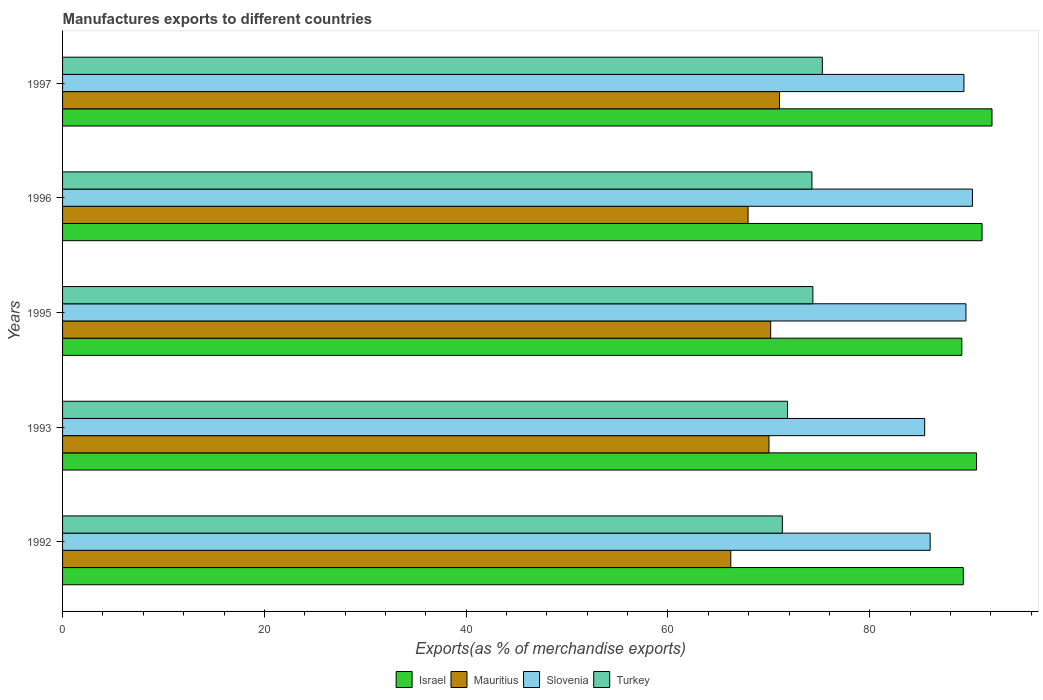How many different coloured bars are there?
Your answer should be compact. 4. Are the number of bars per tick equal to the number of legend labels?
Your answer should be very brief. Yes. Are the number of bars on each tick of the Y-axis equal?
Your answer should be compact. Yes. How many bars are there on the 3rd tick from the top?
Offer a very short reply. 4. What is the percentage of exports to different countries in Israel in 1992?
Give a very brief answer. 89.27. Across all years, what is the maximum percentage of exports to different countries in Turkey?
Provide a short and direct response. 75.3. Across all years, what is the minimum percentage of exports to different countries in Turkey?
Ensure brevity in your answer.  71.34. In which year was the percentage of exports to different countries in Slovenia maximum?
Make the answer very short. 1996. In which year was the percentage of exports to different countries in Slovenia minimum?
Your response must be concise. 1993. What is the total percentage of exports to different countries in Mauritius in the graph?
Give a very brief answer. 345.41. What is the difference between the percentage of exports to different countries in Turkey in 1992 and that in 1996?
Offer a very short reply. -2.93. What is the difference between the percentage of exports to different countries in Mauritius in 1992 and the percentage of exports to different countries in Slovenia in 1995?
Your answer should be compact. -23.31. What is the average percentage of exports to different countries in Israel per year?
Provide a succinct answer. 90.45. In the year 1993, what is the difference between the percentage of exports to different countries in Israel and percentage of exports to different countries in Turkey?
Make the answer very short. 18.73. In how many years, is the percentage of exports to different countries in Mauritius greater than 16 %?
Make the answer very short. 5. What is the ratio of the percentage of exports to different countries in Mauritius in 1992 to that in 1995?
Your response must be concise. 0.94. What is the difference between the highest and the second highest percentage of exports to different countries in Slovenia?
Make the answer very short. 0.64. What is the difference between the highest and the lowest percentage of exports to different countries in Turkey?
Make the answer very short. 3.96. What does the 2nd bar from the top in 1992 represents?
Ensure brevity in your answer.  Slovenia. What does the 3rd bar from the bottom in 1995 represents?
Your answer should be very brief. Slovenia. Is it the case that in every year, the sum of the percentage of exports to different countries in Slovenia and percentage of exports to different countries in Mauritius is greater than the percentage of exports to different countries in Israel?
Provide a short and direct response. Yes. How many bars are there?
Your response must be concise. 20. Are the values on the major ticks of X-axis written in scientific E-notation?
Keep it short and to the point. No. Where does the legend appear in the graph?
Offer a terse response. Bottom center. How many legend labels are there?
Offer a terse response. 4. What is the title of the graph?
Make the answer very short. Manufactures exports to different countries. What is the label or title of the X-axis?
Give a very brief answer. Exports(as % of merchandise exports). What is the label or title of the Y-axis?
Ensure brevity in your answer.  Years. What is the Exports(as % of merchandise exports) in Israel in 1992?
Your answer should be compact. 89.27. What is the Exports(as % of merchandise exports) of Mauritius in 1992?
Your answer should be very brief. 66.23. What is the Exports(as % of merchandise exports) of Slovenia in 1992?
Your answer should be compact. 85.99. What is the Exports(as % of merchandise exports) of Turkey in 1992?
Your answer should be compact. 71.34. What is the Exports(as % of merchandise exports) of Israel in 1993?
Offer a terse response. 90.58. What is the Exports(as % of merchandise exports) in Mauritius in 1993?
Ensure brevity in your answer.  70.01. What is the Exports(as % of merchandise exports) in Slovenia in 1993?
Give a very brief answer. 85.44. What is the Exports(as % of merchandise exports) of Turkey in 1993?
Provide a succinct answer. 71.85. What is the Exports(as % of merchandise exports) of Israel in 1995?
Offer a very short reply. 89.13. What is the Exports(as % of merchandise exports) in Mauritius in 1995?
Offer a very short reply. 70.18. What is the Exports(as % of merchandise exports) in Slovenia in 1995?
Offer a terse response. 89.53. What is the Exports(as % of merchandise exports) of Turkey in 1995?
Provide a short and direct response. 74.36. What is the Exports(as % of merchandise exports) of Israel in 1996?
Ensure brevity in your answer.  91.13. What is the Exports(as % of merchandise exports) in Mauritius in 1996?
Your answer should be very brief. 67.94. What is the Exports(as % of merchandise exports) of Slovenia in 1996?
Your response must be concise. 90.18. What is the Exports(as % of merchandise exports) in Turkey in 1996?
Keep it short and to the point. 74.27. What is the Exports(as % of merchandise exports) in Israel in 1997?
Keep it short and to the point. 92.12. What is the Exports(as % of merchandise exports) of Mauritius in 1997?
Your response must be concise. 71.05. What is the Exports(as % of merchandise exports) in Slovenia in 1997?
Make the answer very short. 89.33. What is the Exports(as % of merchandise exports) in Turkey in 1997?
Ensure brevity in your answer.  75.3. Across all years, what is the maximum Exports(as % of merchandise exports) of Israel?
Your answer should be compact. 92.12. Across all years, what is the maximum Exports(as % of merchandise exports) in Mauritius?
Offer a terse response. 71.05. Across all years, what is the maximum Exports(as % of merchandise exports) in Slovenia?
Your response must be concise. 90.18. Across all years, what is the maximum Exports(as % of merchandise exports) in Turkey?
Provide a succinct answer. 75.3. Across all years, what is the minimum Exports(as % of merchandise exports) in Israel?
Your response must be concise. 89.13. Across all years, what is the minimum Exports(as % of merchandise exports) of Mauritius?
Give a very brief answer. 66.23. Across all years, what is the minimum Exports(as % of merchandise exports) in Slovenia?
Your answer should be very brief. 85.44. Across all years, what is the minimum Exports(as % of merchandise exports) of Turkey?
Provide a succinct answer. 71.34. What is the total Exports(as % of merchandise exports) of Israel in the graph?
Provide a short and direct response. 452.23. What is the total Exports(as % of merchandise exports) in Mauritius in the graph?
Your answer should be very brief. 345.41. What is the total Exports(as % of merchandise exports) of Slovenia in the graph?
Ensure brevity in your answer.  440.47. What is the total Exports(as % of merchandise exports) in Turkey in the graph?
Your answer should be very brief. 367.12. What is the difference between the Exports(as % of merchandise exports) of Israel in 1992 and that in 1993?
Your answer should be very brief. -1.31. What is the difference between the Exports(as % of merchandise exports) of Mauritius in 1992 and that in 1993?
Give a very brief answer. -3.78. What is the difference between the Exports(as % of merchandise exports) in Slovenia in 1992 and that in 1993?
Provide a succinct answer. 0.54. What is the difference between the Exports(as % of merchandise exports) in Turkey in 1992 and that in 1993?
Keep it short and to the point. -0.51. What is the difference between the Exports(as % of merchandise exports) of Israel in 1992 and that in 1995?
Give a very brief answer. 0.15. What is the difference between the Exports(as % of merchandise exports) of Mauritius in 1992 and that in 1995?
Provide a short and direct response. -3.95. What is the difference between the Exports(as % of merchandise exports) in Slovenia in 1992 and that in 1995?
Give a very brief answer. -3.55. What is the difference between the Exports(as % of merchandise exports) in Turkey in 1992 and that in 1995?
Ensure brevity in your answer.  -3.03. What is the difference between the Exports(as % of merchandise exports) of Israel in 1992 and that in 1996?
Provide a short and direct response. -1.86. What is the difference between the Exports(as % of merchandise exports) of Mauritius in 1992 and that in 1996?
Your answer should be very brief. -1.71. What is the difference between the Exports(as % of merchandise exports) of Slovenia in 1992 and that in 1996?
Offer a terse response. -4.19. What is the difference between the Exports(as % of merchandise exports) of Turkey in 1992 and that in 1996?
Provide a short and direct response. -2.93. What is the difference between the Exports(as % of merchandise exports) in Israel in 1992 and that in 1997?
Offer a terse response. -2.85. What is the difference between the Exports(as % of merchandise exports) of Mauritius in 1992 and that in 1997?
Your response must be concise. -4.83. What is the difference between the Exports(as % of merchandise exports) of Slovenia in 1992 and that in 1997?
Offer a terse response. -3.35. What is the difference between the Exports(as % of merchandise exports) in Turkey in 1992 and that in 1997?
Keep it short and to the point. -3.96. What is the difference between the Exports(as % of merchandise exports) of Israel in 1993 and that in 1995?
Ensure brevity in your answer.  1.46. What is the difference between the Exports(as % of merchandise exports) of Mauritius in 1993 and that in 1995?
Keep it short and to the point. -0.17. What is the difference between the Exports(as % of merchandise exports) in Slovenia in 1993 and that in 1995?
Give a very brief answer. -4.09. What is the difference between the Exports(as % of merchandise exports) of Turkey in 1993 and that in 1995?
Your response must be concise. -2.52. What is the difference between the Exports(as % of merchandise exports) of Israel in 1993 and that in 1996?
Give a very brief answer. -0.55. What is the difference between the Exports(as % of merchandise exports) in Mauritius in 1993 and that in 1996?
Offer a very short reply. 2.07. What is the difference between the Exports(as % of merchandise exports) in Slovenia in 1993 and that in 1996?
Your answer should be compact. -4.73. What is the difference between the Exports(as % of merchandise exports) of Turkey in 1993 and that in 1996?
Offer a terse response. -2.42. What is the difference between the Exports(as % of merchandise exports) in Israel in 1993 and that in 1997?
Offer a terse response. -1.54. What is the difference between the Exports(as % of merchandise exports) of Mauritius in 1993 and that in 1997?
Your answer should be compact. -1.04. What is the difference between the Exports(as % of merchandise exports) in Slovenia in 1993 and that in 1997?
Keep it short and to the point. -3.89. What is the difference between the Exports(as % of merchandise exports) of Turkey in 1993 and that in 1997?
Your answer should be compact. -3.45. What is the difference between the Exports(as % of merchandise exports) of Israel in 1995 and that in 1996?
Ensure brevity in your answer.  -2.01. What is the difference between the Exports(as % of merchandise exports) in Mauritius in 1995 and that in 1996?
Your answer should be very brief. 2.24. What is the difference between the Exports(as % of merchandise exports) in Slovenia in 1995 and that in 1996?
Your answer should be compact. -0.64. What is the difference between the Exports(as % of merchandise exports) of Turkey in 1995 and that in 1996?
Offer a very short reply. 0.09. What is the difference between the Exports(as % of merchandise exports) of Israel in 1995 and that in 1997?
Provide a short and direct response. -2.99. What is the difference between the Exports(as % of merchandise exports) of Mauritius in 1995 and that in 1997?
Your response must be concise. -0.87. What is the difference between the Exports(as % of merchandise exports) of Slovenia in 1995 and that in 1997?
Make the answer very short. 0.2. What is the difference between the Exports(as % of merchandise exports) of Turkey in 1995 and that in 1997?
Give a very brief answer. -0.93. What is the difference between the Exports(as % of merchandise exports) in Israel in 1996 and that in 1997?
Ensure brevity in your answer.  -0.99. What is the difference between the Exports(as % of merchandise exports) of Mauritius in 1996 and that in 1997?
Offer a very short reply. -3.12. What is the difference between the Exports(as % of merchandise exports) of Slovenia in 1996 and that in 1997?
Ensure brevity in your answer.  0.84. What is the difference between the Exports(as % of merchandise exports) of Turkey in 1996 and that in 1997?
Provide a succinct answer. -1.03. What is the difference between the Exports(as % of merchandise exports) of Israel in 1992 and the Exports(as % of merchandise exports) of Mauritius in 1993?
Your answer should be very brief. 19.26. What is the difference between the Exports(as % of merchandise exports) in Israel in 1992 and the Exports(as % of merchandise exports) in Slovenia in 1993?
Make the answer very short. 3.83. What is the difference between the Exports(as % of merchandise exports) in Israel in 1992 and the Exports(as % of merchandise exports) in Turkey in 1993?
Ensure brevity in your answer.  17.42. What is the difference between the Exports(as % of merchandise exports) of Mauritius in 1992 and the Exports(as % of merchandise exports) of Slovenia in 1993?
Give a very brief answer. -19.21. What is the difference between the Exports(as % of merchandise exports) in Mauritius in 1992 and the Exports(as % of merchandise exports) in Turkey in 1993?
Your answer should be compact. -5.62. What is the difference between the Exports(as % of merchandise exports) in Slovenia in 1992 and the Exports(as % of merchandise exports) in Turkey in 1993?
Provide a succinct answer. 14.14. What is the difference between the Exports(as % of merchandise exports) of Israel in 1992 and the Exports(as % of merchandise exports) of Mauritius in 1995?
Make the answer very short. 19.09. What is the difference between the Exports(as % of merchandise exports) of Israel in 1992 and the Exports(as % of merchandise exports) of Slovenia in 1995?
Ensure brevity in your answer.  -0.26. What is the difference between the Exports(as % of merchandise exports) in Israel in 1992 and the Exports(as % of merchandise exports) in Turkey in 1995?
Keep it short and to the point. 14.91. What is the difference between the Exports(as % of merchandise exports) in Mauritius in 1992 and the Exports(as % of merchandise exports) in Slovenia in 1995?
Offer a terse response. -23.31. What is the difference between the Exports(as % of merchandise exports) of Mauritius in 1992 and the Exports(as % of merchandise exports) of Turkey in 1995?
Offer a terse response. -8.14. What is the difference between the Exports(as % of merchandise exports) of Slovenia in 1992 and the Exports(as % of merchandise exports) of Turkey in 1995?
Provide a short and direct response. 11.62. What is the difference between the Exports(as % of merchandise exports) in Israel in 1992 and the Exports(as % of merchandise exports) in Mauritius in 1996?
Offer a very short reply. 21.33. What is the difference between the Exports(as % of merchandise exports) of Israel in 1992 and the Exports(as % of merchandise exports) of Slovenia in 1996?
Ensure brevity in your answer.  -0.9. What is the difference between the Exports(as % of merchandise exports) in Israel in 1992 and the Exports(as % of merchandise exports) in Turkey in 1996?
Provide a succinct answer. 15. What is the difference between the Exports(as % of merchandise exports) in Mauritius in 1992 and the Exports(as % of merchandise exports) in Slovenia in 1996?
Your answer should be compact. -23.95. What is the difference between the Exports(as % of merchandise exports) of Mauritius in 1992 and the Exports(as % of merchandise exports) of Turkey in 1996?
Keep it short and to the point. -8.04. What is the difference between the Exports(as % of merchandise exports) of Slovenia in 1992 and the Exports(as % of merchandise exports) of Turkey in 1996?
Ensure brevity in your answer.  11.72. What is the difference between the Exports(as % of merchandise exports) in Israel in 1992 and the Exports(as % of merchandise exports) in Mauritius in 1997?
Provide a short and direct response. 18.22. What is the difference between the Exports(as % of merchandise exports) in Israel in 1992 and the Exports(as % of merchandise exports) in Slovenia in 1997?
Make the answer very short. -0.06. What is the difference between the Exports(as % of merchandise exports) of Israel in 1992 and the Exports(as % of merchandise exports) of Turkey in 1997?
Provide a succinct answer. 13.97. What is the difference between the Exports(as % of merchandise exports) in Mauritius in 1992 and the Exports(as % of merchandise exports) in Slovenia in 1997?
Offer a terse response. -23.11. What is the difference between the Exports(as % of merchandise exports) of Mauritius in 1992 and the Exports(as % of merchandise exports) of Turkey in 1997?
Provide a succinct answer. -9.07. What is the difference between the Exports(as % of merchandise exports) in Slovenia in 1992 and the Exports(as % of merchandise exports) in Turkey in 1997?
Your response must be concise. 10.69. What is the difference between the Exports(as % of merchandise exports) in Israel in 1993 and the Exports(as % of merchandise exports) in Mauritius in 1995?
Make the answer very short. 20.4. What is the difference between the Exports(as % of merchandise exports) in Israel in 1993 and the Exports(as % of merchandise exports) in Slovenia in 1995?
Offer a very short reply. 1.05. What is the difference between the Exports(as % of merchandise exports) in Israel in 1993 and the Exports(as % of merchandise exports) in Turkey in 1995?
Your answer should be compact. 16.22. What is the difference between the Exports(as % of merchandise exports) in Mauritius in 1993 and the Exports(as % of merchandise exports) in Slovenia in 1995?
Keep it short and to the point. -19.52. What is the difference between the Exports(as % of merchandise exports) in Mauritius in 1993 and the Exports(as % of merchandise exports) in Turkey in 1995?
Offer a terse response. -4.35. What is the difference between the Exports(as % of merchandise exports) in Slovenia in 1993 and the Exports(as % of merchandise exports) in Turkey in 1995?
Your answer should be very brief. 11.08. What is the difference between the Exports(as % of merchandise exports) in Israel in 1993 and the Exports(as % of merchandise exports) in Mauritius in 1996?
Your response must be concise. 22.64. What is the difference between the Exports(as % of merchandise exports) of Israel in 1993 and the Exports(as % of merchandise exports) of Slovenia in 1996?
Offer a very short reply. 0.41. What is the difference between the Exports(as % of merchandise exports) in Israel in 1993 and the Exports(as % of merchandise exports) in Turkey in 1996?
Your answer should be compact. 16.31. What is the difference between the Exports(as % of merchandise exports) of Mauritius in 1993 and the Exports(as % of merchandise exports) of Slovenia in 1996?
Give a very brief answer. -20.16. What is the difference between the Exports(as % of merchandise exports) of Mauritius in 1993 and the Exports(as % of merchandise exports) of Turkey in 1996?
Your answer should be compact. -4.26. What is the difference between the Exports(as % of merchandise exports) in Slovenia in 1993 and the Exports(as % of merchandise exports) in Turkey in 1996?
Offer a very short reply. 11.17. What is the difference between the Exports(as % of merchandise exports) in Israel in 1993 and the Exports(as % of merchandise exports) in Mauritius in 1997?
Make the answer very short. 19.53. What is the difference between the Exports(as % of merchandise exports) in Israel in 1993 and the Exports(as % of merchandise exports) in Slovenia in 1997?
Keep it short and to the point. 1.25. What is the difference between the Exports(as % of merchandise exports) of Israel in 1993 and the Exports(as % of merchandise exports) of Turkey in 1997?
Your response must be concise. 15.28. What is the difference between the Exports(as % of merchandise exports) in Mauritius in 1993 and the Exports(as % of merchandise exports) in Slovenia in 1997?
Provide a short and direct response. -19.32. What is the difference between the Exports(as % of merchandise exports) in Mauritius in 1993 and the Exports(as % of merchandise exports) in Turkey in 1997?
Make the answer very short. -5.29. What is the difference between the Exports(as % of merchandise exports) of Slovenia in 1993 and the Exports(as % of merchandise exports) of Turkey in 1997?
Make the answer very short. 10.14. What is the difference between the Exports(as % of merchandise exports) of Israel in 1995 and the Exports(as % of merchandise exports) of Mauritius in 1996?
Make the answer very short. 21.19. What is the difference between the Exports(as % of merchandise exports) in Israel in 1995 and the Exports(as % of merchandise exports) in Slovenia in 1996?
Provide a succinct answer. -1.05. What is the difference between the Exports(as % of merchandise exports) in Israel in 1995 and the Exports(as % of merchandise exports) in Turkey in 1996?
Your answer should be compact. 14.86. What is the difference between the Exports(as % of merchandise exports) in Mauritius in 1995 and the Exports(as % of merchandise exports) in Slovenia in 1996?
Your response must be concise. -19.99. What is the difference between the Exports(as % of merchandise exports) of Mauritius in 1995 and the Exports(as % of merchandise exports) of Turkey in 1996?
Your answer should be compact. -4.09. What is the difference between the Exports(as % of merchandise exports) of Slovenia in 1995 and the Exports(as % of merchandise exports) of Turkey in 1996?
Give a very brief answer. 15.26. What is the difference between the Exports(as % of merchandise exports) in Israel in 1995 and the Exports(as % of merchandise exports) in Mauritius in 1997?
Offer a very short reply. 18.07. What is the difference between the Exports(as % of merchandise exports) in Israel in 1995 and the Exports(as % of merchandise exports) in Slovenia in 1997?
Provide a succinct answer. -0.21. What is the difference between the Exports(as % of merchandise exports) of Israel in 1995 and the Exports(as % of merchandise exports) of Turkey in 1997?
Offer a very short reply. 13.83. What is the difference between the Exports(as % of merchandise exports) in Mauritius in 1995 and the Exports(as % of merchandise exports) in Slovenia in 1997?
Offer a terse response. -19.15. What is the difference between the Exports(as % of merchandise exports) of Mauritius in 1995 and the Exports(as % of merchandise exports) of Turkey in 1997?
Make the answer very short. -5.12. What is the difference between the Exports(as % of merchandise exports) of Slovenia in 1995 and the Exports(as % of merchandise exports) of Turkey in 1997?
Offer a very short reply. 14.23. What is the difference between the Exports(as % of merchandise exports) in Israel in 1996 and the Exports(as % of merchandise exports) in Mauritius in 1997?
Your response must be concise. 20.08. What is the difference between the Exports(as % of merchandise exports) of Israel in 1996 and the Exports(as % of merchandise exports) of Slovenia in 1997?
Provide a short and direct response. 1.8. What is the difference between the Exports(as % of merchandise exports) of Israel in 1996 and the Exports(as % of merchandise exports) of Turkey in 1997?
Your response must be concise. 15.83. What is the difference between the Exports(as % of merchandise exports) in Mauritius in 1996 and the Exports(as % of merchandise exports) in Slovenia in 1997?
Give a very brief answer. -21.4. What is the difference between the Exports(as % of merchandise exports) in Mauritius in 1996 and the Exports(as % of merchandise exports) in Turkey in 1997?
Provide a succinct answer. -7.36. What is the difference between the Exports(as % of merchandise exports) in Slovenia in 1996 and the Exports(as % of merchandise exports) in Turkey in 1997?
Offer a terse response. 14.88. What is the average Exports(as % of merchandise exports) of Israel per year?
Ensure brevity in your answer.  90.45. What is the average Exports(as % of merchandise exports) in Mauritius per year?
Keep it short and to the point. 69.08. What is the average Exports(as % of merchandise exports) of Slovenia per year?
Your answer should be very brief. 88.09. What is the average Exports(as % of merchandise exports) in Turkey per year?
Offer a terse response. 73.42. In the year 1992, what is the difference between the Exports(as % of merchandise exports) in Israel and Exports(as % of merchandise exports) in Mauritius?
Your answer should be compact. 23.04. In the year 1992, what is the difference between the Exports(as % of merchandise exports) in Israel and Exports(as % of merchandise exports) in Slovenia?
Provide a short and direct response. 3.29. In the year 1992, what is the difference between the Exports(as % of merchandise exports) in Israel and Exports(as % of merchandise exports) in Turkey?
Keep it short and to the point. 17.93. In the year 1992, what is the difference between the Exports(as % of merchandise exports) in Mauritius and Exports(as % of merchandise exports) in Slovenia?
Your response must be concise. -19.76. In the year 1992, what is the difference between the Exports(as % of merchandise exports) of Mauritius and Exports(as % of merchandise exports) of Turkey?
Keep it short and to the point. -5.11. In the year 1992, what is the difference between the Exports(as % of merchandise exports) of Slovenia and Exports(as % of merchandise exports) of Turkey?
Offer a very short reply. 14.65. In the year 1993, what is the difference between the Exports(as % of merchandise exports) of Israel and Exports(as % of merchandise exports) of Mauritius?
Ensure brevity in your answer.  20.57. In the year 1993, what is the difference between the Exports(as % of merchandise exports) in Israel and Exports(as % of merchandise exports) in Slovenia?
Your answer should be compact. 5.14. In the year 1993, what is the difference between the Exports(as % of merchandise exports) in Israel and Exports(as % of merchandise exports) in Turkey?
Provide a succinct answer. 18.73. In the year 1993, what is the difference between the Exports(as % of merchandise exports) in Mauritius and Exports(as % of merchandise exports) in Slovenia?
Provide a succinct answer. -15.43. In the year 1993, what is the difference between the Exports(as % of merchandise exports) of Mauritius and Exports(as % of merchandise exports) of Turkey?
Keep it short and to the point. -1.84. In the year 1993, what is the difference between the Exports(as % of merchandise exports) of Slovenia and Exports(as % of merchandise exports) of Turkey?
Give a very brief answer. 13.59. In the year 1995, what is the difference between the Exports(as % of merchandise exports) of Israel and Exports(as % of merchandise exports) of Mauritius?
Make the answer very short. 18.94. In the year 1995, what is the difference between the Exports(as % of merchandise exports) in Israel and Exports(as % of merchandise exports) in Slovenia?
Offer a very short reply. -0.41. In the year 1995, what is the difference between the Exports(as % of merchandise exports) of Israel and Exports(as % of merchandise exports) of Turkey?
Provide a short and direct response. 14.76. In the year 1995, what is the difference between the Exports(as % of merchandise exports) in Mauritius and Exports(as % of merchandise exports) in Slovenia?
Your answer should be very brief. -19.35. In the year 1995, what is the difference between the Exports(as % of merchandise exports) in Mauritius and Exports(as % of merchandise exports) in Turkey?
Ensure brevity in your answer.  -4.18. In the year 1995, what is the difference between the Exports(as % of merchandise exports) in Slovenia and Exports(as % of merchandise exports) in Turkey?
Make the answer very short. 15.17. In the year 1996, what is the difference between the Exports(as % of merchandise exports) of Israel and Exports(as % of merchandise exports) of Mauritius?
Offer a very short reply. 23.19. In the year 1996, what is the difference between the Exports(as % of merchandise exports) of Israel and Exports(as % of merchandise exports) of Slovenia?
Provide a succinct answer. 0.96. In the year 1996, what is the difference between the Exports(as % of merchandise exports) in Israel and Exports(as % of merchandise exports) in Turkey?
Offer a very short reply. 16.86. In the year 1996, what is the difference between the Exports(as % of merchandise exports) in Mauritius and Exports(as % of merchandise exports) in Slovenia?
Your response must be concise. -22.24. In the year 1996, what is the difference between the Exports(as % of merchandise exports) of Mauritius and Exports(as % of merchandise exports) of Turkey?
Offer a terse response. -6.33. In the year 1996, what is the difference between the Exports(as % of merchandise exports) of Slovenia and Exports(as % of merchandise exports) of Turkey?
Your answer should be very brief. 15.91. In the year 1997, what is the difference between the Exports(as % of merchandise exports) of Israel and Exports(as % of merchandise exports) of Mauritius?
Your answer should be compact. 21.06. In the year 1997, what is the difference between the Exports(as % of merchandise exports) in Israel and Exports(as % of merchandise exports) in Slovenia?
Provide a succinct answer. 2.78. In the year 1997, what is the difference between the Exports(as % of merchandise exports) of Israel and Exports(as % of merchandise exports) of Turkey?
Ensure brevity in your answer.  16.82. In the year 1997, what is the difference between the Exports(as % of merchandise exports) in Mauritius and Exports(as % of merchandise exports) in Slovenia?
Provide a short and direct response. -18.28. In the year 1997, what is the difference between the Exports(as % of merchandise exports) of Mauritius and Exports(as % of merchandise exports) of Turkey?
Your answer should be very brief. -4.24. In the year 1997, what is the difference between the Exports(as % of merchandise exports) in Slovenia and Exports(as % of merchandise exports) in Turkey?
Give a very brief answer. 14.04. What is the ratio of the Exports(as % of merchandise exports) of Israel in 1992 to that in 1993?
Give a very brief answer. 0.99. What is the ratio of the Exports(as % of merchandise exports) of Mauritius in 1992 to that in 1993?
Your answer should be compact. 0.95. What is the ratio of the Exports(as % of merchandise exports) in Slovenia in 1992 to that in 1993?
Keep it short and to the point. 1.01. What is the ratio of the Exports(as % of merchandise exports) in Mauritius in 1992 to that in 1995?
Offer a very short reply. 0.94. What is the ratio of the Exports(as % of merchandise exports) of Slovenia in 1992 to that in 1995?
Provide a short and direct response. 0.96. What is the ratio of the Exports(as % of merchandise exports) in Turkey in 1992 to that in 1995?
Offer a very short reply. 0.96. What is the ratio of the Exports(as % of merchandise exports) of Israel in 1992 to that in 1996?
Keep it short and to the point. 0.98. What is the ratio of the Exports(as % of merchandise exports) in Mauritius in 1992 to that in 1996?
Provide a short and direct response. 0.97. What is the ratio of the Exports(as % of merchandise exports) of Slovenia in 1992 to that in 1996?
Give a very brief answer. 0.95. What is the ratio of the Exports(as % of merchandise exports) of Turkey in 1992 to that in 1996?
Your answer should be very brief. 0.96. What is the ratio of the Exports(as % of merchandise exports) of Israel in 1992 to that in 1997?
Provide a succinct answer. 0.97. What is the ratio of the Exports(as % of merchandise exports) in Mauritius in 1992 to that in 1997?
Offer a terse response. 0.93. What is the ratio of the Exports(as % of merchandise exports) in Slovenia in 1992 to that in 1997?
Offer a terse response. 0.96. What is the ratio of the Exports(as % of merchandise exports) in Turkey in 1992 to that in 1997?
Make the answer very short. 0.95. What is the ratio of the Exports(as % of merchandise exports) of Israel in 1993 to that in 1995?
Make the answer very short. 1.02. What is the ratio of the Exports(as % of merchandise exports) of Mauritius in 1993 to that in 1995?
Make the answer very short. 1. What is the ratio of the Exports(as % of merchandise exports) in Slovenia in 1993 to that in 1995?
Make the answer very short. 0.95. What is the ratio of the Exports(as % of merchandise exports) in Turkey in 1993 to that in 1995?
Keep it short and to the point. 0.97. What is the ratio of the Exports(as % of merchandise exports) of Israel in 1993 to that in 1996?
Provide a succinct answer. 0.99. What is the ratio of the Exports(as % of merchandise exports) in Mauritius in 1993 to that in 1996?
Make the answer very short. 1.03. What is the ratio of the Exports(as % of merchandise exports) of Slovenia in 1993 to that in 1996?
Ensure brevity in your answer.  0.95. What is the ratio of the Exports(as % of merchandise exports) in Turkey in 1993 to that in 1996?
Your answer should be compact. 0.97. What is the ratio of the Exports(as % of merchandise exports) of Israel in 1993 to that in 1997?
Your answer should be compact. 0.98. What is the ratio of the Exports(as % of merchandise exports) of Slovenia in 1993 to that in 1997?
Make the answer very short. 0.96. What is the ratio of the Exports(as % of merchandise exports) of Turkey in 1993 to that in 1997?
Ensure brevity in your answer.  0.95. What is the ratio of the Exports(as % of merchandise exports) in Israel in 1995 to that in 1996?
Your response must be concise. 0.98. What is the ratio of the Exports(as % of merchandise exports) of Mauritius in 1995 to that in 1996?
Provide a short and direct response. 1.03. What is the ratio of the Exports(as % of merchandise exports) of Turkey in 1995 to that in 1996?
Keep it short and to the point. 1. What is the ratio of the Exports(as % of merchandise exports) of Israel in 1995 to that in 1997?
Provide a short and direct response. 0.97. What is the ratio of the Exports(as % of merchandise exports) of Mauritius in 1995 to that in 1997?
Make the answer very short. 0.99. What is the ratio of the Exports(as % of merchandise exports) of Slovenia in 1995 to that in 1997?
Ensure brevity in your answer.  1. What is the ratio of the Exports(as % of merchandise exports) of Turkey in 1995 to that in 1997?
Ensure brevity in your answer.  0.99. What is the ratio of the Exports(as % of merchandise exports) in Israel in 1996 to that in 1997?
Make the answer very short. 0.99. What is the ratio of the Exports(as % of merchandise exports) in Mauritius in 1996 to that in 1997?
Offer a terse response. 0.96. What is the ratio of the Exports(as % of merchandise exports) in Slovenia in 1996 to that in 1997?
Your answer should be very brief. 1.01. What is the ratio of the Exports(as % of merchandise exports) of Turkey in 1996 to that in 1997?
Provide a short and direct response. 0.99. What is the difference between the highest and the second highest Exports(as % of merchandise exports) of Israel?
Ensure brevity in your answer.  0.99. What is the difference between the highest and the second highest Exports(as % of merchandise exports) in Mauritius?
Ensure brevity in your answer.  0.87. What is the difference between the highest and the second highest Exports(as % of merchandise exports) in Slovenia?
Your response must be concise. 0.64. What is the difference between the highest and the second highest Exports(as % of merchandise exports) of Turkey?
Offer a very short reply. 0.93. What is the difference between the highest and the lowest Exports(as % of merchandise exports) in Israel?
Keep it short and to the point. 2.99. What is the difference between the highest and the lowest Exports(as % of merchandise exports) in Mauritius?
Offer a very short reply. 4.83. What is the difference between the highest and the lowest Exports(as % of merchandise exports) of Slovenia?
Your response must be concise. 4.73. What is the difference between the highest and the lowest Exports(as % of merchandise exports) of Turkey?
Offer a terse response. 3.96. 